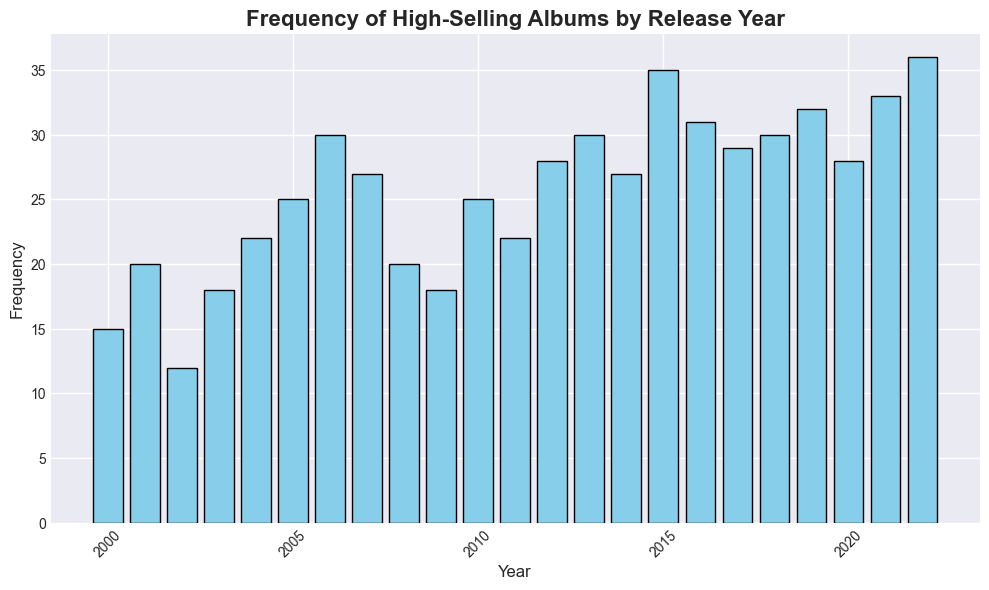What year saw the highest frequency of high-selling albums? Examine the height of the bars in the histogram and identify the year with the tallest bar.
Answer: 2022 Which year had a lower frequency of high-selling albums: 2003 or 2008? Compare the heights of the bars for the years 2003 and 2008 in the histogram.
Answer: 2003 What is the average frequency of high-selling albums from 2010 to 2015? Sum the frequencies from 2010 to 2015 (25, 22, 28, 30, 27, 35) and then divide by the number of years (6). (25 + 22 + 28 + 30 + 27 + 35) / 6 = 167 / 6
Answer: 27.83 How much did the frequency of high-selling albums increase from 2002 to 2005? Find the difference between the frequencies in 2005 and 2002: 25 (2005) - 12 (2002) = 13.
Answer: 13 Compare the frequencies of high-selling albums in 2019 and 2021. Which year had a higher frequency? Look at the bars for 2019 and 2021 and compare their heights. 2021 has a taller bar than 2019.
Answer: 2021 What's the cumulative frequency of high-selling albums from 2000 to 2005? Sum the frequencies from 2000 to 2005 (15, 20, 12, 18, 22, 25). 15 + 20 + 12 + 18 + 22 + 25 = 112.
Answer: 112 Which decade had a higher total frequency of high-selling albums, 2000-2009 or 2010-2019? Sum the frequencies for each decade. For 2000-2009: 15+20+12+18+22+25+30+27+20+18 = 207. For 2010-2019: 25+22+28+30+27+35+31+29+30+32 = 289. Compare the two sums.
Answer: 2010-2019 By how much did the frequency change from 2018 to 2019? Subtract the 2018 frequency from the 2019 frequency: 32 (2019) - 30 (2018) = 2.
Answer: 2 What is the frequency range of high-selling albums from 2000 to 2022? Find the difference between the maximum and minimum frequencies in the histogram data. Maximum is 36 (2022) and minimum is 12 (2002). 36 - 12 = 24.
Answer: 24 